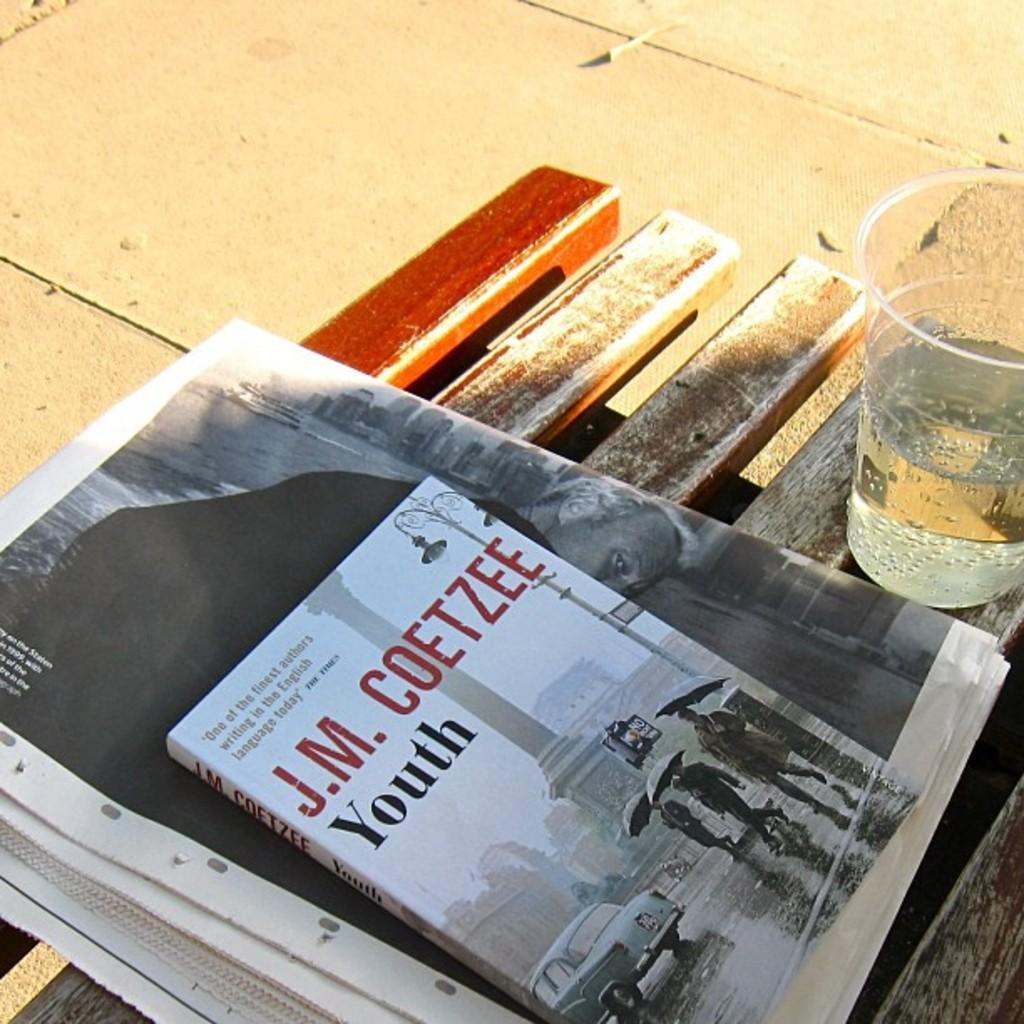<image>
Give a short and clear explanation of the subsequent image. A copy of the book youth by JM Coetzee is sitting on top of a newspaper. 